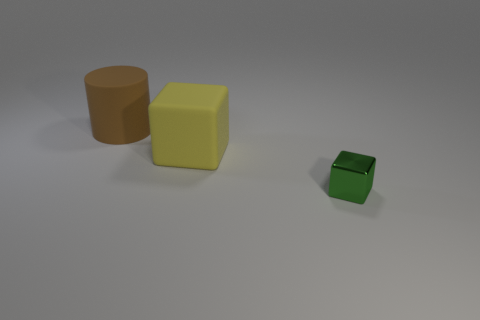Is the number of brown rubber cylinders greater than the number of red cylinders?
Your answer should be very brief. Yes. Do the large object that is on the right side of the brown cylinder and the large brown cylinder have the same material?
Give a very brief answer. Yes. Is the number of cubes less than the number of things?
Make the answer very short. Yes. Is there a yellow matte block that is on the right side of the small object that is right of the block that is on the left side of the tiny metal block?
Ensure brevity in your answer.  No. Do the big rubber thing that is on the left side of the large cube and the small thing have the same shape?
Your answer should be very brief. No. Is the number of large yellow things that are behind the tiny green cube greater than the number of gray rubber cubes?
Your answer should be very brief. Yes. Is there any other thing that has the same color as the large block?
Give a very brief answer. No. The large rubber thing that is to the right of the large rubber cylinder that is behind the block to the left of the small block is what color?
Keep it short and to the point. Yellow. Do the rubber cylinder and the metal cube have the same size?
Your answer should be very brief. No. What number of gray matte cylinders are the same size as the yellow thing?
Provide a succinct answer. 0. 